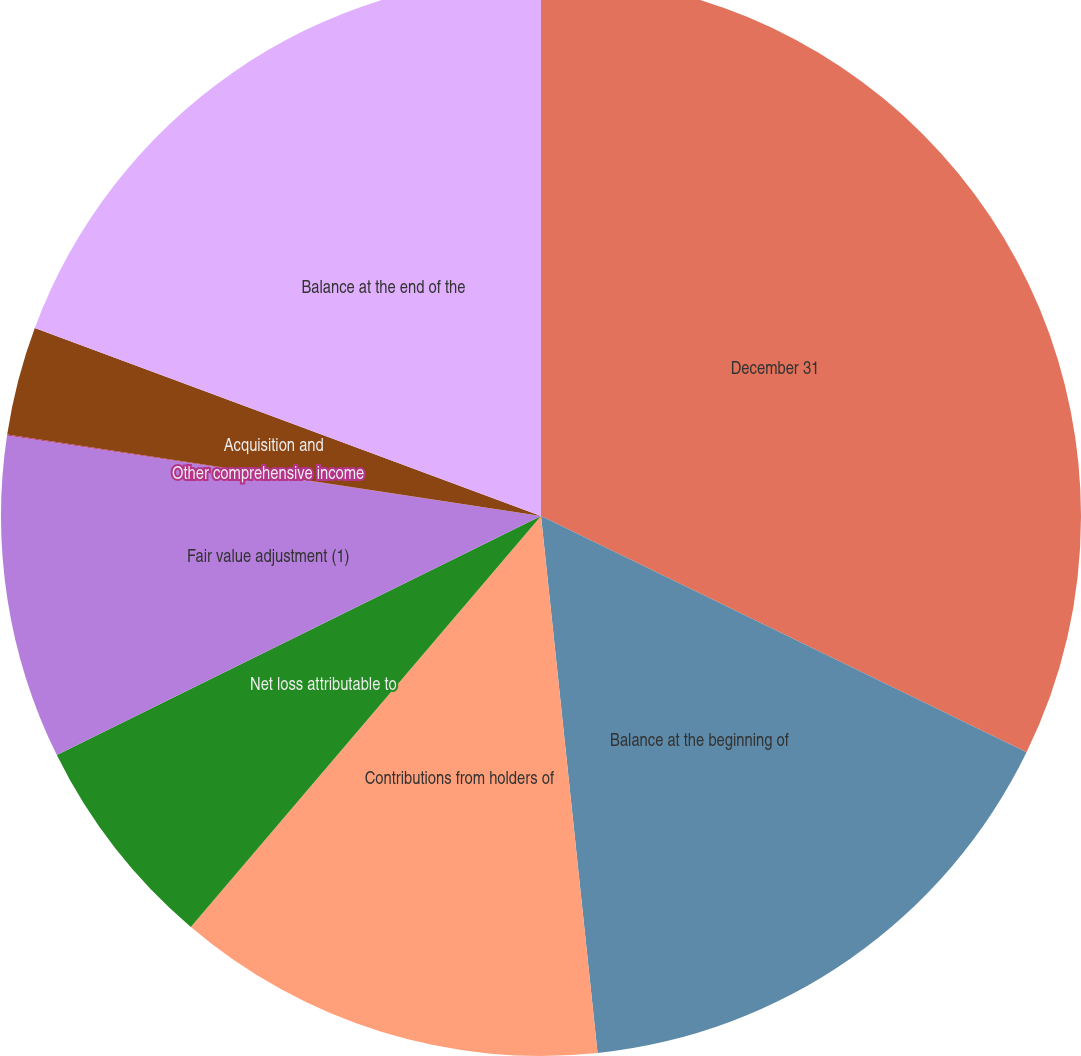Convert chart. <chart><loc_0><loc_0><loc_500><loc_500><pie_chart><fcel>December 31<fcel>Balance at the beginning of<fcel>Contributions from holders of<fcel>Net loss attributable to<fcel>Fair value adjustment (1)<fcel>Other comprehensive income<fcel>Acquisition and<fcel>Balance at the end of the<nl><fcel>32.21%<fcel>16.12%<fcel>12.9%<fcel>6.47%<fcel>9.68%<fcel>0.03%<fcel>3.25%<fcel>19.34%<nl></chart> 